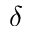<formula> <loc_0><loc_0><loc_500><loc_500>\delta</formula> 